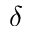<formula> <loc_0><loc_0><loc_500><loc_500>\delta</formula> 